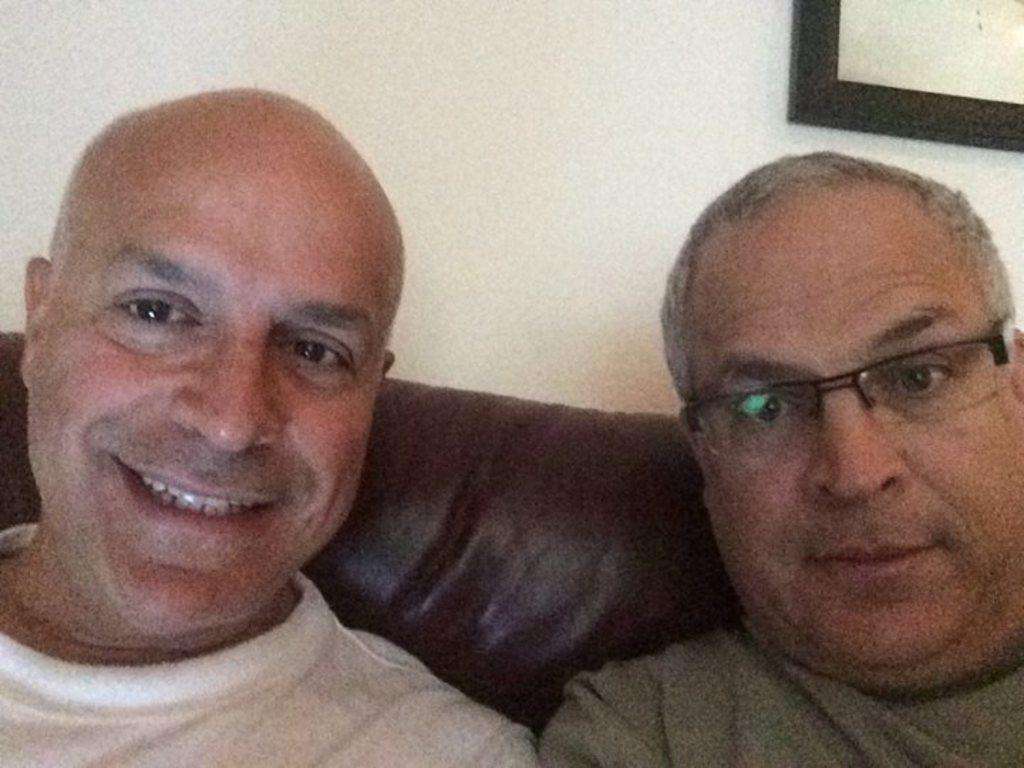How many people are in the image? There are two persons in the image. What are the persons doing in the image? The persons are sitting on a sofa. Can you describe anything on the wall in the background of the image? There is a photo frame on the wall in the background of the image. What type of bread can be seen on the fork in the image? There is no fork or bread present in the image. 